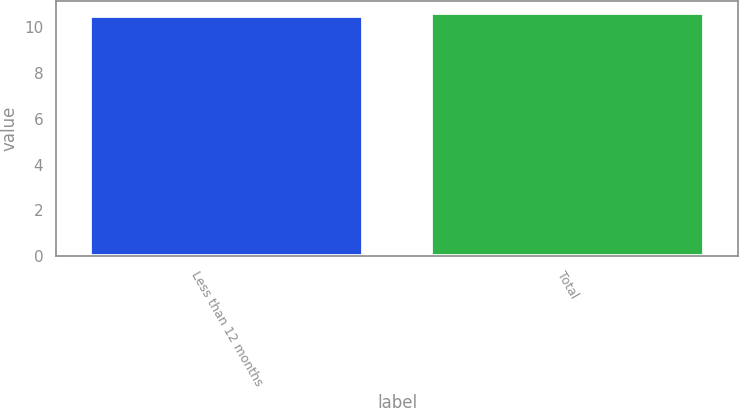<chart> <loc_0><loc_0><loc_500><loc_500><bar_chart><fcel>Less than 12 months<fcel>Total<nl><fcel>10.5<fcel>10.6<nl></chart> 